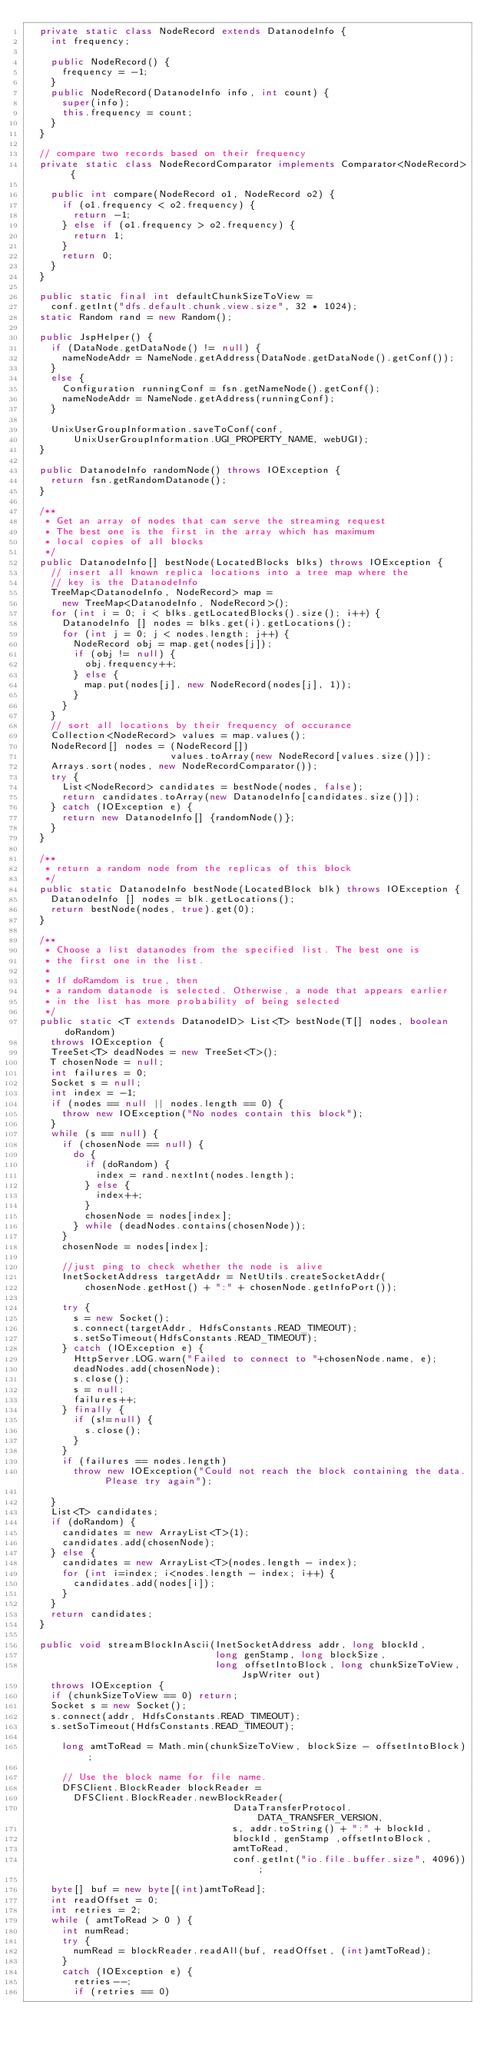Convert code to text. <code><loc_0><loc_0><loc_500><loc_500><_Java_>  private static class NodeRecord extends DatanodeInfo {
    int frequency;

    public NodeRecord() {
      frequency = -1;
    }
    public NodeRecord(DatanodeInfo info, int count) {
      super(info);
      this.frequency = count;
    }
  }
 
  // compare two records based on their frequency
  private static class NodeRecordComparator implements Comparator<NodeRecord> {

    public int compare(NodeRecord o1, NodeRecord o2) {
      if (o1.frequency < o2.frequency) {
        return -1;
      } else if (o1.frequency > o2.frequency) {
        return 1;
      } 
      return 0;
    }
  }

  public static final int defaultChunkSizeToView = 
    conf.getInt("dfs.default.chunk.view.size", 32 * 1024);
  static Random rand = new Random();

  public JspHelper() {
    if (DataNode.getDataNode() != null) {
      nameNodeAddr = NameNode.getAddress(DataNode.getDataNode().getConf());
    }
    else {
      Configuration runningConf = fsn.getNameNode().getConf();
      nameNodeAddr = NameNode.getAddress(runningConf); 
    }      

    UnixUserGroupInformation.saveToConf(conf,
        UnixUserGroupInformation.UGI_PROPERTY_NAME, webUGI);
  }

  public DatanodeInfo randomNode() throws IOException {
    return fsn.getRandomDatanode();
  }

  /**
   * Get an array of nodes that can serve the streaming request
   * The best one is the first in the array which has maximum 
   * local copies of all blocks
   */
  public DatanodeInfo[] bestNode(LocatedBlocks blks) throws IOException {
    // insert all known replica locations into a tree map where the
    // key is the DatanodeInfo
    TreeMap<DatanodeInfo, NodeRecord> map = 
      new TreeMap<DatanodeInfo, NodeRecord>();
    for (int i = 0; i < blks.getLocatedBlocks().size(); i++) {
      DatanodeInfo [] nodes = blks.get(i).getLocations();
      for (int j = 0; j < nodes.length; j++) {
        NodeRecord obj = map.get(nodes[j]);
        if (obj != null) {
          obj.frequency++;
        } else {
          map.put(nodes[j], new NodeRecord(nodes[j], 1));
        }
      }
    }
    // sort all locations by their frequency of occurance
    Collection<NodeRecord> values = map.values();
    NodeRecord[] nodes = (NodeRecord[]) 
                         values.toArray(new NodeRecord[values.size()]);
    Arrays.sort(nodes, new NodeRecordComparator());
    try {
      List<NodeRecord> candidates = bestNode(nodes, false);
      return candidates.toArray(new DatanodeInfo[candidates.size()]);
    } catch (IOException e) {
      return new DatanodeInfo[] {randomNode()};
    }
  }

  /**
   * return a random node from the replicas of this block
   */
  public static DatanodeInfo bestNode(LocatedBlock blk) throws IOException {
    DatanodeInfo [] nodes = blk.getLocations();
    return bestNode(nodes, true).get(0);
  }

  /**
   * Choose a list datanodes from the specified list. The best one is
   * the first one in the list.
   * 
   * If doRamdom is true, then
   * a random datanode is selected. Otherwise, a node that appears earlier
   * in the list has more probability of being selected
   */
  public static <T extends DatanodeID> List<T> bestNode(T[] nodes, boolean doRandom) 
    throws IOException {
    TreeSet<T> deadNodes = new TreeSet<T>();
    T chosenNode = null;
    int failures = 0;
    Socket s = null;
    int index = -1;
    if (nodes == null || nodes.length == 0) {
      throw new IOException("No nodes contain this block");
    }
    while (s == null) {
      if (chosenNode == null) {
        do {
          if (doRandom) {
            index = rand.nextInt(nodes.length);
          } else {
            index++;
          }
          chosenNode = nodes[index];
        } while (deadNodes.contains(chosenNode));
      }
      chosenNode = nodes[index];

      //just ping to check whether the node is alive
      InetSocketAddress targetAddr = NetUtils.createSocketAddr(
          chosenNode.getHost() + ":" + chosenNode.getInfoPort());
        
      try {
        s = new Socket();
        s.connect(targetAddr, HdfsConstants.READ_TIMEOUT);
        s.setSoTimeout(HdfsConstants.READ_TIMEOUT);
      } catch (IOException e) {
        HttpServer.LOG.warn("Failed to connect to "+chosenNode.name, e);
        deadNodes.add(chosenNode);
        s.close();
        s = null;
        failures++;
      } finally {
        if (s!=null) {
          s.close();
        }
      }
      if (failures == nodes.length)
        throw new IOException("Could not reach the block containing the data. Please try again");
        
    }
    List<T> candidates;
    if (doRandom) {
      candidates = new ArrayList<T>(1);
      candidates.add(chosenNode);
    } else {
      candidates = new ArrayList<T>(nodes.length - index);
      for (int i=index; i<nodes.length - index; i++) {
        candidates.add(nodes[i]);
      }
    }
    return candidates;
  }
  
  public void streamBlockInAscii(InetSocketAddress addr, long blockId, 
                                 long genStamp, long blockSize, 
                                 long offsetIntoBlock, long chunkSizeToView, JspWriter out) 
    throws IOException {
    if (chunkSizeToView == 0) return;
    Socket s = new Socket();
    s.connect(addr, HdfsConstants.READ_TIMEOUT);
    s.setSoTimeout(HdfsConstants.READ_TIMEOUT);
      
      long amtToRead = Math.min(chunkSizeToView, blockSize - offsetIntoBlock);     
      
      // Use the block name for file name. 
      DFSClient.BlockReader blockReader = 
        DFSClient.BlockReader.newBlockReader(
                                    DataTransferProtocol.DATA_TRANSFER_VERSION,
                                    s, addr.toString() + ":" + blockId,
                                    blockId, genStamp ,offsetIntoBlock, 
                                    amtToRead, 
                                    conf.getInt("io.file.buffer.size", 4096));
        
    byte[] buf = new byte[(int)amtToRead];
    int readOffset = 0;
    int retries = 2;
    while ( amtToRead > 0 ) {
      int numRead;
      try {
        numRead = blockReader.readAll(buf, readOffset, (int)amtToRead);
      }
      catch (IOException e) {
        retries--;
        if (retries == 0)</code> 